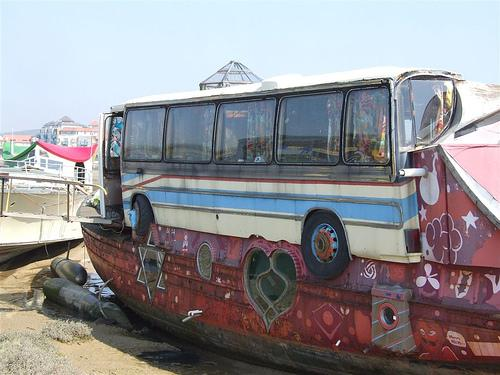List the various notable attributes and unique features of the boat. The boat is red, combined with a bus, featuring a Star of David, a heart, and a cloud design, along with heart, star, and round shaped windows. Point out the main form of transportation in the image. The main form of transportation is a large blue and white bus that has been merged with a red boat. Describe the image's weather and setting in one sentence. The scene takes place outdoors under a clear blue sky. Provide a concise description of the image's theme. The scene depicts an unusual outdoor setting with a bus-boat combination, colorful structures, and a clear blue sky. Briefly describe the transportation in the image and the surrounding environment. The image features a bus-boat combination parked on sand near buildings with colorful roofs, under a clear blue sky. Identify any symbols present in the image and their significance. There is a Star of David on the boat, which could represent Jewish identity or beliefs, and a heart design, possibly symbolizing love or affection. Discuss the state of the bus and describe its placement. The bus is stationary, not moving, and built into the top of a red custom boat on sandy ground close to buildings with colorful rooftops. Mention the key elements of the scene and their interaction. A large blue and white bus is built into the top of a red custom boat with unique designs and windows, parked on sand near a building with a green and red roof. Narrate the peculiar aspects of the windows in the image. Various windows are present on the bus and boat, such as large, clear windows on the bus, a glass dome on a blue building, and heart, star, and round shaped windows on the boat. Describe the color scheme and decorative elements on the bus part of the object. The bus is blue and white with a clear, large front window, an open door, and a picture of a white clover leaf on the side. A large purple balloon is floating above the bus. No, it's not mentioned in the image. 